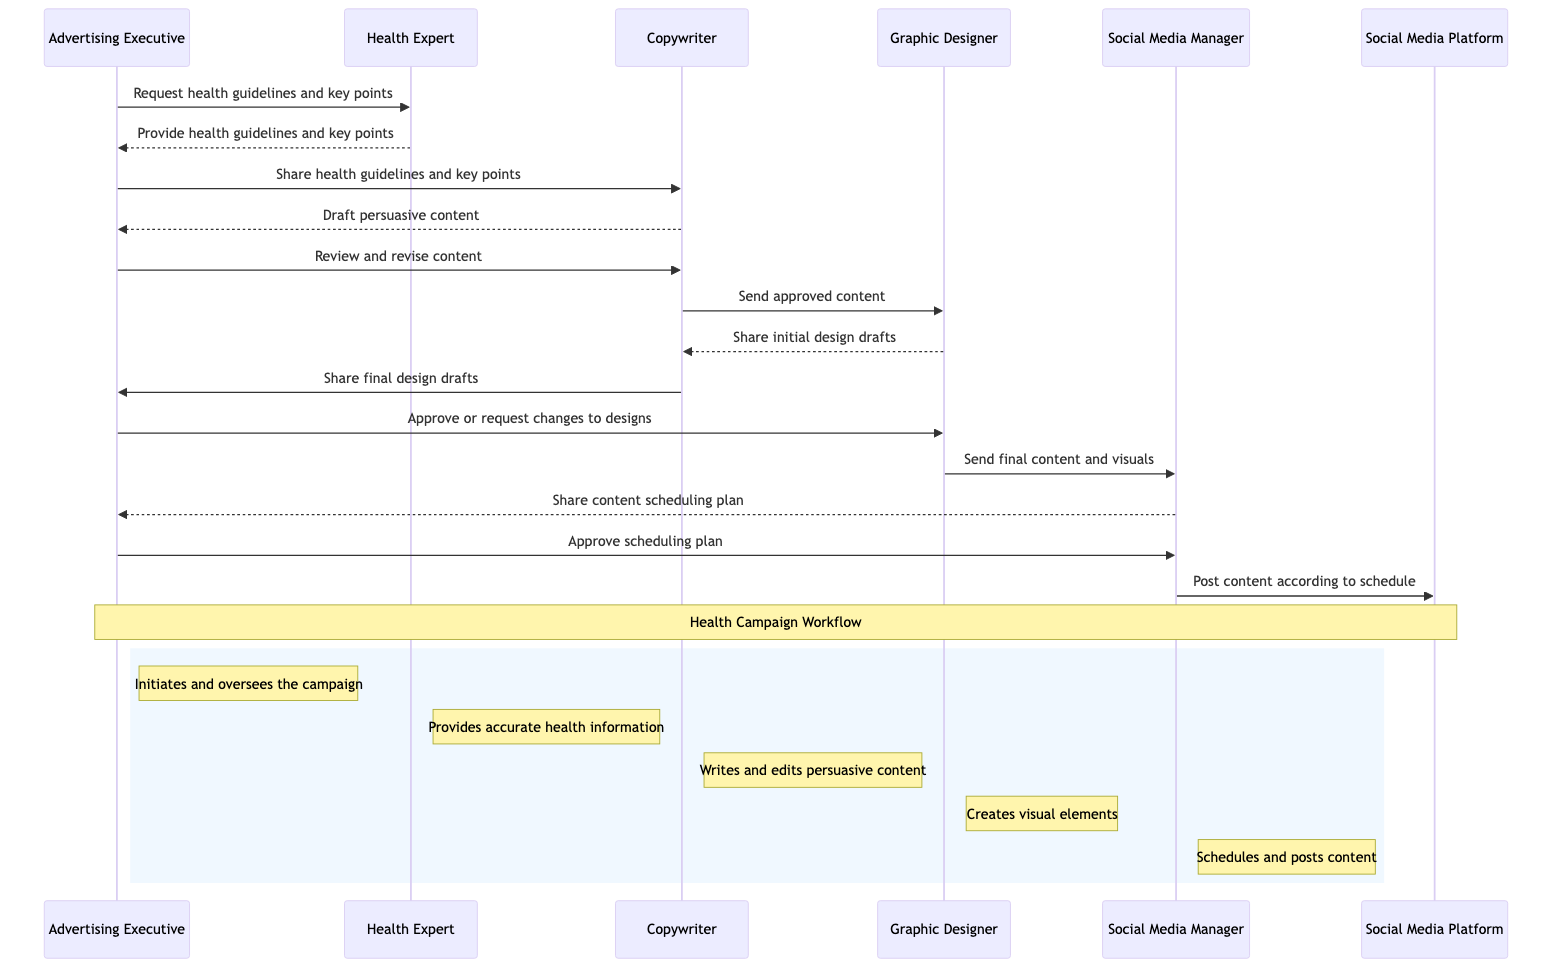What is the role of the Advertising Executive? The Advertising Executive initiates and oversees the campaign, coordinating the efforts of all other actors.
Answer: Initiates and oversees the campaign How many interactions are there in the workflow? By counting all the messages sent between participants, we find that there are a total of 13 interactions in the workflow.
Answer: 13 Who receives the health guidelines after the Health Expert provides them? The Advertising Executive is the next receiver after the Health Expert sends the guidelines, as per the flow of interactions.
Answer: Advertising Executive What does the Copywriter send to the Graphic Designer? The Copywriter sends the approved content to the Graphic Designer as part of the collaborative process to create visuals for the campaign.
Answer: Approved content Which participant shares the content scheduling plan with the Advertising Executive? The Social Media Manager is responsible for sharing the content scheduling plan before it is approved by the Advertising Executive.
Answer: Social Media Manager What action does the Graphic Designer take after receiving the approved content? After receiving the approved content, the Graphic Designer sends the final content and visuals to the Social Media Manager for scheduling and posting.
Answer: Send final content and visuals What decision does the Advertising Executive make regarding content and visuals? The Advertising Executive either approves or requests changes to the designs shared by the Graphic Designer, ensuring the content aligns with campaign standards.
Answer: Approve or request changes What does the Social Media Manager do last in the workflow? The final action taken by the Social Media Manager is to post the content according to the approved scheduling plan.
Answer: Post content according to schedule Who first requests the health guidelines? The first request for health guidelines is made by the Advertising Executive, initiating the flow of information necessary for content creation.
Answer: Advertising Executive 